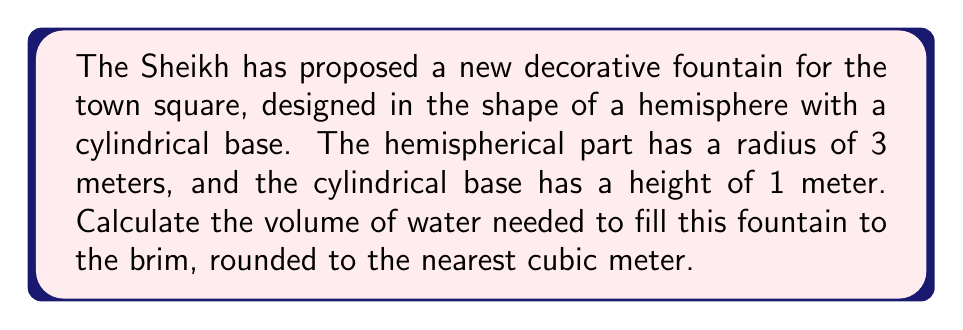Teach me how to tackle this problem. Let's approach this step-by-step:

1) The fountain consists of two parts: a hemisphere and a cylinder. We need to calculate the volume of each and add them together.

2) Volume of the hemisphere:
   The formula for the volume of a hemisphere is:
   $$V_{hemisphere} = \frac{2}{3}\pi r^3$$
   Where $r$ is the radius.
   $$V_{hemisphere} = \frac{2}{3}\pi (3m)^3 = 18\pi \approx 56.55 m^3$$

3) Volume of the cylinder:
   The formula for the volume of a cylinder is:
   $$V_{cylinder} = \pi r^2 h$$
   Where $r$ is the radius of the base (same as the hemisphere) and $h$ is the height.
   $$V_{cylinder} = \pi (3m)^2 (1m) = 9\pi \approx 28.27 m^3$$

4) Total volume:
   $$V_{total} = V_{hemisphere} + V_{cylinder} = 18\pi + 9\pi = 27\pi \approx 84.82 m^3$$

5) Rounding to the nearest cubic meter:
   84.82 rounds to 85 m³

[asy]
import three;

size(200);
currentprojection=perspective(6,3,2);

// Draw the cylinder
draw(cylinder((0,0,0),3,1));

// Draw the hemisphere
draw(shift(0,0,1)*surface(sphere(3)),blue+opacity(0.5));

// Draw the axes
draw(O--4X,arrow=Arrow3);
draw(O--4Y,arrow=Arrow3);
draw(O--4Z,arrow=Arrow3);

label("x",4X,W);
label("y",4Y,N);
label("z",4Z,E);
[/asy]
Answer: 85 m³ 